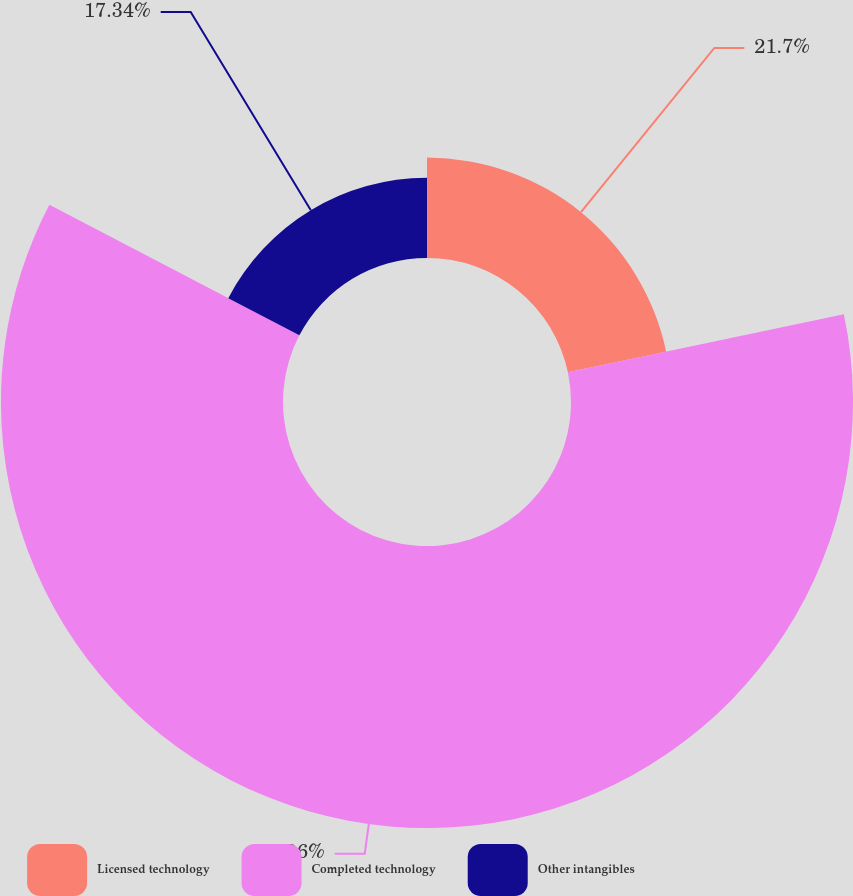Convert chart. <chart><loc_0><loc_0><loc_500><loc_500><pie_chart><fcel>Licensed technology<fcel>Completed technology<fcel>Other intangibles<nl><fcel>21.7%<fcel>60.96%<fcel>17.34%<nl></chart> 